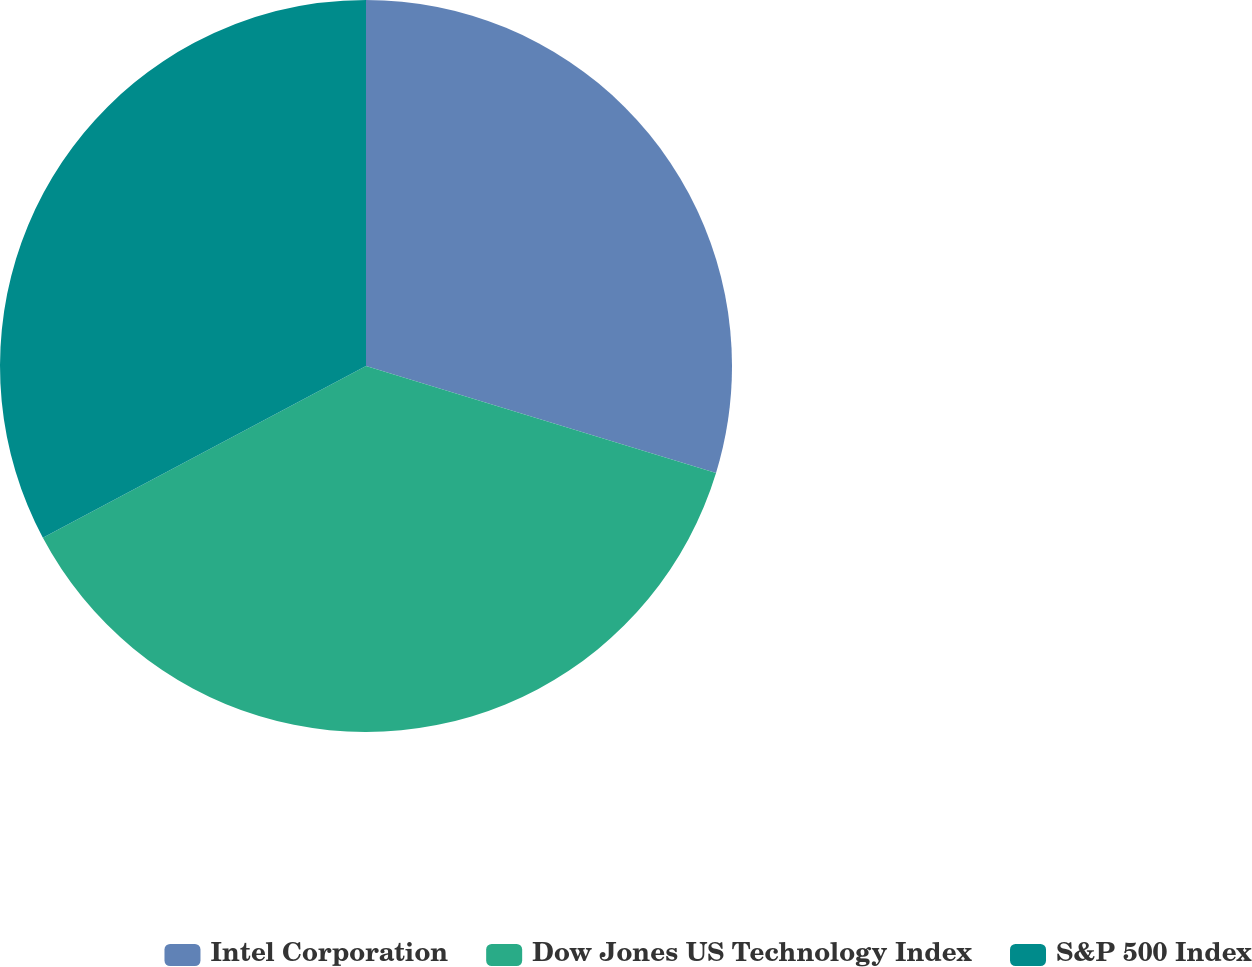<chart> <loc_0><loc_0><loc_500><loc_500><pie_chart><fcel>Intel Corporation<fcel>Dow Jones US Technology Index<fcel>S&P 500 Index<nl><fcel>29.72%<fcel>37.5%<fcel>32.78%<nl></chart> 